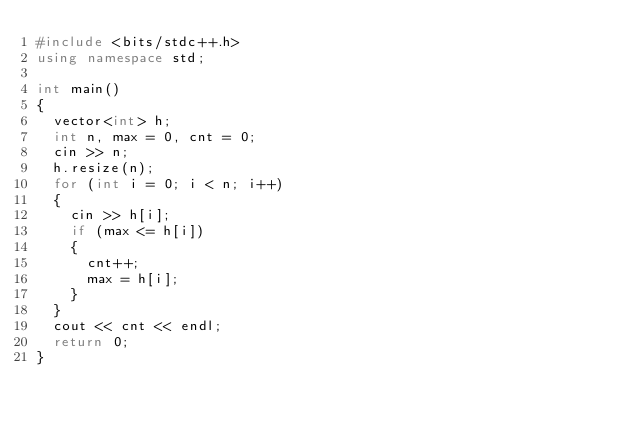Convert code to text. <code><loc_0><loc_0><loc_500><loc_500><_C++_>#include <bits/stdc++.h>
using namespace std;

int main()
{
	vector<int> h;
	int n, max = 0, cnt = 0;
	cin >> n;
	h.resize(n);
	for (int i = 0; i < n; i++)
	{
		cin >> h[i];
		if (max <= h[i])
		{
			cnt++;
			max = h[i];
		}
	}
	cout << cnt << endl;
	return 0;
}
</code> 